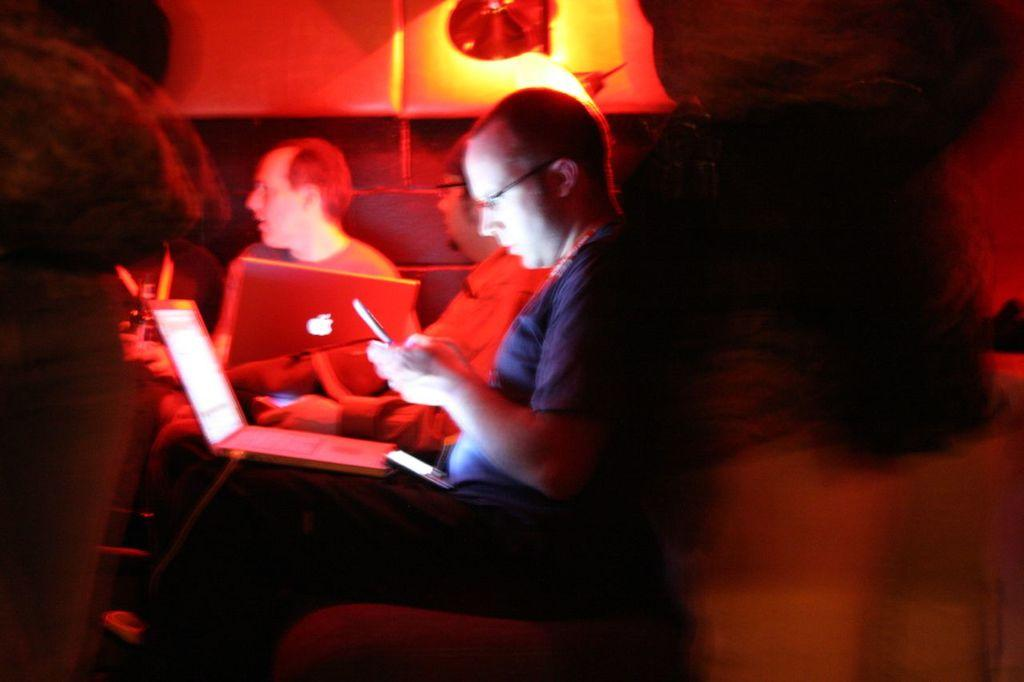What is the person in the image doing? There is a person sitting on a sofa in the image. What object is the person holding while sitting on the sofa? The person is holding a laptop on their lap. What sound can be heard coming from the laptop in the image? There is no information about the laptop's sound in the image, so it cannot be determined. 